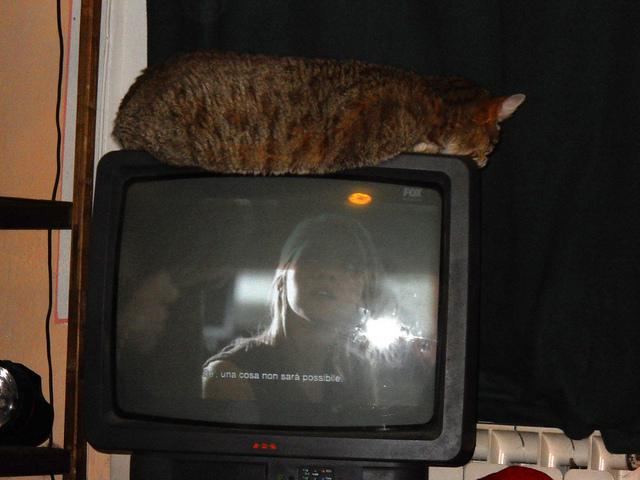Why is the cat sitting here? Please explain your reasoning. warmth. The cat is sitting on top of the television for warmth. 